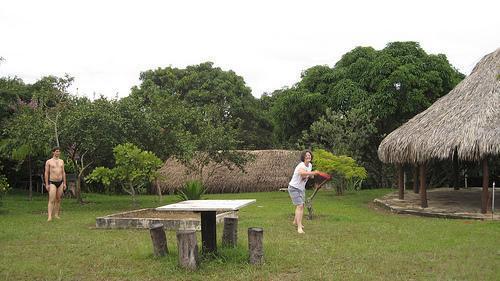How many people do you see?
Give a very brief answer. 2. 